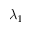Convert formula to latex. <formula><loc_0><loc_0><loc_500><loc_500>\lambda _ { 1 }</formula> 